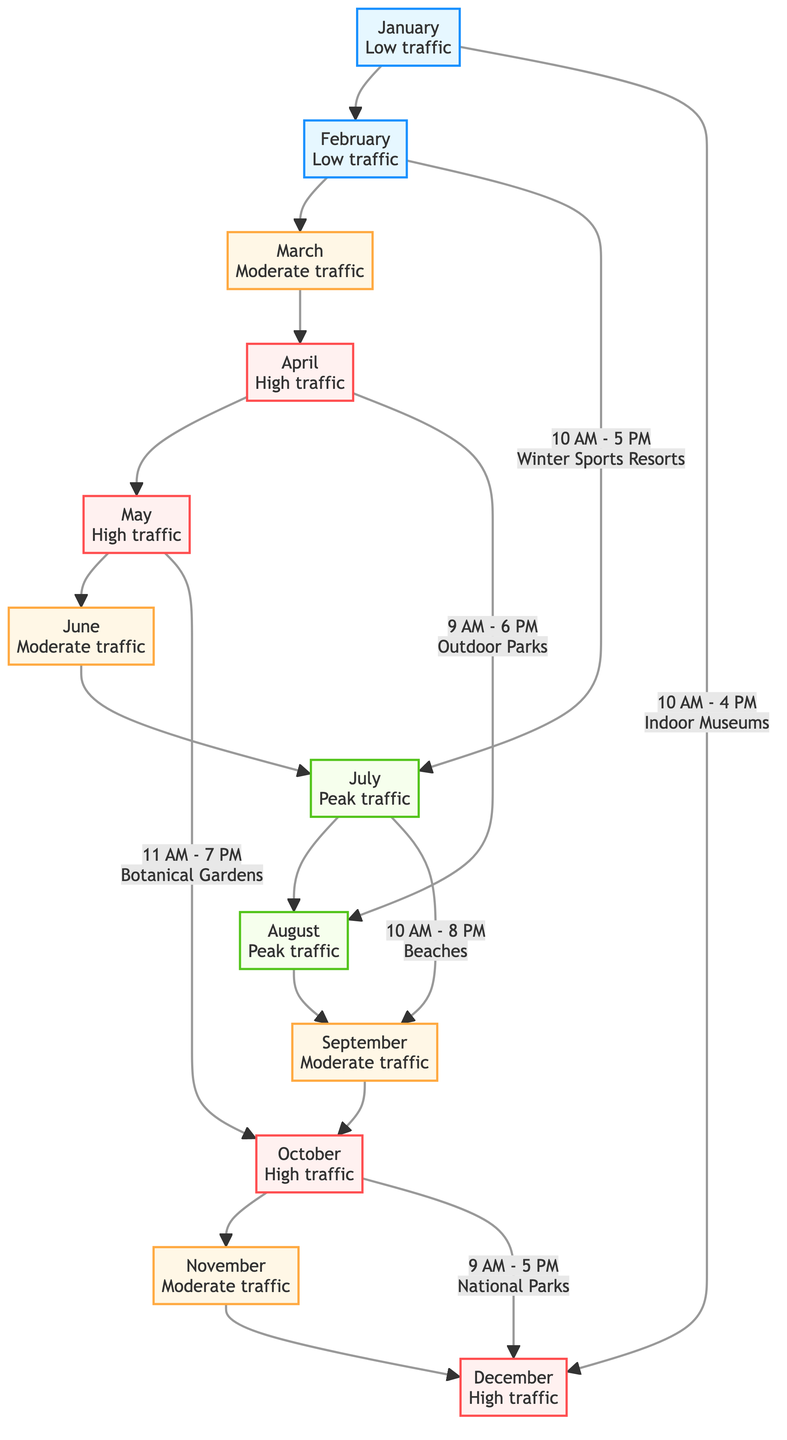What month has peak traffic? The diagram shows July and August highlighted as having "Peak traffic," which indicates these are the months with the highest visitor flow.
Answer: July, August Which month shows low traffic? The diagram indicates January and February as experiencing "Low traffic," meaning these months have fewer visitors compared to others.
Answer: January, February What are the peak hours for beaches? The diagram states that the peak hours for beaches, indicated for July, are "10 AM - 8 PM," signifying when the most visitors are expected.
Answer: 10 AM - 8 PM How many months are marked with high traffic? The diagram visually illustrates four months—April, May, October, and December—labeled as "High traffic."
Answer: Four What popular attraction is linked to April? It shows that April is connected to "Outdoor Parks" as the popular attraction associated with it, designated by its high traffic status.
Answer: Outdoor Parks Which month has moderate traffic before peak months? The moderate traffic months before peak traffic in July and August are June and March, as indicated in the flow.
Answer: June, March What is the traffic flow trend from January to December? The diagram depicts a gradual increase from low traffic in January to peak in July and August, followed by a decline toward moderate and high traffic in the latter months of the year.
Answer: Gradual increase and decrease What is the traffic status in September? According to the diagram, September is marked with "Moderate traffic," indicating visitor levels are neither low nor high.
Answer: Moderate traffic Which attraction is associated with October? It is shown that "National Parks" are the popular attraction linked to October, as indicated by its traffic level.
Answer: National Parks 